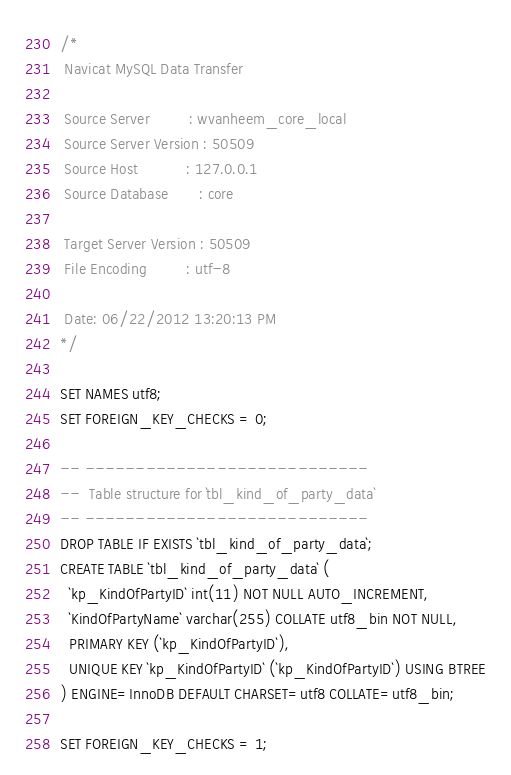Convert code to text. <code><loc_0><loc_0><loc_500><loc_500><_SQL_>/*
 Navicat MySQL Data Transfer

 Source Server         : wvanheem_core_local
 Source Server Version : 50509
 Source Host           : 127.0.0.1
 Source Database       : core

 Target Server Version : 50509
 File Encoding         : utf-8

 Date: 06/22/2012 13:20:13 PM
*/

SET NAMES utf8;
SET FOREIGN_KEY_CHECKS = 0;

-- ----------------------------
--  Table structure for `tbl_kind_of_party_data`
-- ----------------------------
DROP TABLE IF EXISTS `tbl_kind_of_party_data`;
CREATE TABLE `tbl_kind_of_party_data` (
  `kp_KindOfPartyID` int(11) NOT NULL AUTO_INCREMENT,
  `KindOfPartyName` varchar(255) COLLATE utf8_bin NOT NULL,
  PRIMARY KEY (`kp_KindOfPartyID`),
  UNIQUE KEY `kp_KindOfPartyID` (`kp_KindOfPartyID`) USING BTREE
) ENGINE=InnoDB DEFAULT CHARSET=utf8 COLLATE=utf8_bin;

SET FOREIGN_KEY_CHECKS = 1;
</code> 